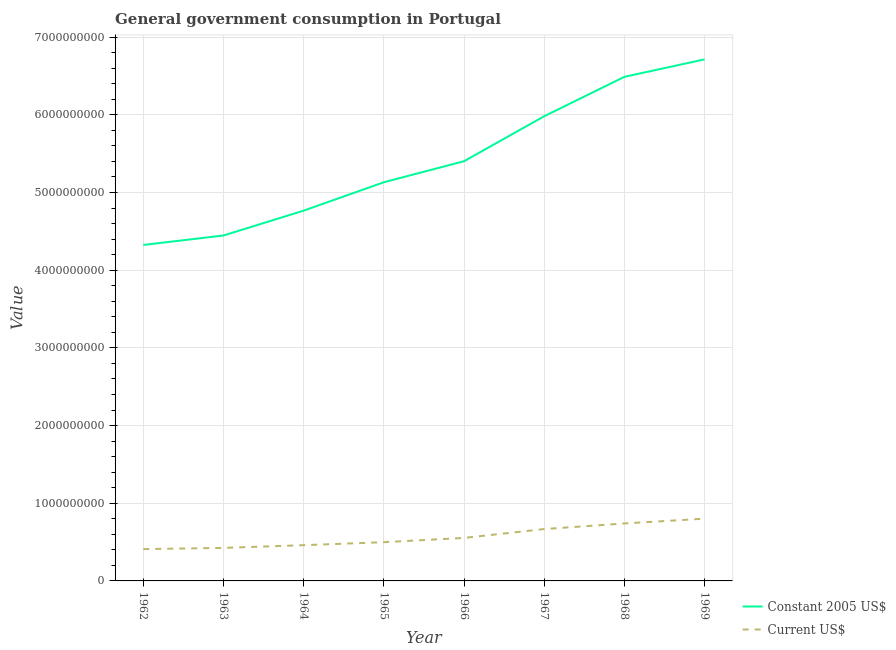How many different coloured lines are there?
Ensure brevity in your answer.  2. Does the line corresponding to value consumed in constant 2005 us$ intersect with the line corresponding to value consumed in current us$?
Your answer should be very brief. No. What is the value consumed in constant 2005 us$ in 1962?
Your answer should be compact. 4.32e+09. Across all years, what is the maximum value consumed in constant 2005 us$?
Your response must be concise. 6.71e+09. Across all years, what is the minimum value consumed in constant 2005 us$?
Keep it short and to the point. 4.32e+09. In which year was the value consumed in constant 2005 us$ maximum?
Your answer should be compact. 1969. In which year was the value consumed in constant 2005 us$ minimum?
Offer a very short reply. 1962. What is the total value consumed in constant 2005 us$ in the graph?
Your answer should be compact. 4.33e+1. What is the difference between the value consumed in constant 2005 us$ in 1963 and that in 1969?
Provide a succinct answer. -2.27e+09. What is the difference between the value consumed in current us$ in 1967 and the value consumed in constant 2005 us$ in 1963?
Offer a very short reply. -3.78e+09. What is the average value consumed in constant 2005 us$ per year?
Provide a succinct answer. 5.41e+09. In the year 1965, what is the difference between the value consumed in constant 2005 us$ and value consumed in current us$?
Offer a terse response. 4.63e+09. What is the ratio of the value consumed in current us$ in 1962 to that in 1965?
Make the answer very short. 0.82. Is the value consumed in constant 2005 us$ in 1966 less than that in 1968?
Provide a succinct answer. Yes. Is the difference between the value consumed in constant 2005 us$ in 1963 and 1965 greater than the difference between the value consumed in current us$ in 1963 and 1965?
Offer a very short reply. No. What is the difference between the highest and the second highest value consumed in constant 2005 us$?
Give a very brief answer. 2.25e+08. What is the difference between the highest and the lowest value consumed in constant 2005 us$?
Keep it short and to the point. 2.39e+09. Is the value consumed in constant 2005 us$ strictly greater than the value consumed in current us$ over the years?
Your response must be concise. Yes. Is the value consumed in constant 2005 us$ strictly less than the value consumed in current us$ over the years?
Offer a very short reply. No. How many lines are there?
Give a very brief answer. 2. How many years are there in the graph?
Make the answer very short. 8. What is the difference between two consecutive major ticks on the Y-axis?
Offer a very short reply. 1.00e+09. Are the values on the major ticks of Y-axis written in scientific E-notation?
Your answer should be compact. No. Where does the legend appear in the graph?
Your response must be concise. Bottom right. How many legend labels are there?
Offer a terse response. 2. How are the legend labels stacked?
Ensure brevity in your answer.  Vertical. What is the title of the graph?
Keep it short and to the point. General government consumption in Portugal. Does "Imports" appear as one of the legend labels in the graph?
Your answer should be compact. No. What is the label or title of the X-axis?
Your answer should be compact. Year. What is the label or title of the Y-axis?
Make the answer very short. Value. What is the Value of Constant 2005 US$ in 1962?
Ensure brevity in your answer.  4.32e+09. What is the Value of Current US$ in 1962?
Keep it short and to the point. 4.09e+08. What is the Value of Constant 2005 US$ in 1963?
Your answer should be very brief. 4.45e+09. What is the Value of Current US$ in 1963?
Your answer should be compact. 4.25e+08. What is the Value in Constant 2005 US$ in 1964?
Make the answer very short. 4.77e+09. What is the Value in Current US$ in 1964?
Offer a very short reply. 4.60e+08. What is the Value in Constant 2005 US$ in 1965?
Make the answer very short. 5.13e+09. What is the Value of Current US$ in 1965?
Offer a very short reply. 4.99e+08. What is the Value in Constant 2005 US$ in 1966?
Offer a terse response. 5.40e+09. What is the Value in Current US$ in 1966?
Ensure brevity in your answer.  5.53e+08. What is the Value of Constant 2005 US$ in 1967?
Give a very brief answer. 5.98e+09. What is the Value of Current US$ in 1967?
Make the answer very short. 6.68e+08. What is the Value of Constant 2005 US$ in 1968?
Ensure brevity in your answer.  6.49e+09. What is the Value in Current US$ in 1968?
Offer a very short reply. 7.40e+08. What is the Value in Constant 2005 US$ in 1969?
Offer a terse response. 6.71e+09. What is the Value of Current US$ in 1969?
Keep it short and to the point. 8.02e+08. Across all years, what is the maximum Value of Constant 2005 US$?
Provide a short and direct response. 6.71e+09. Across all years, what is the maximum Value of Current US$?
Your answer should be very brief. 8.02e+08. Across all years, what is the minimum Value of Constant 2005 US$?
Provide a short and direct response. 4.32e+09. Across all years, what is the minimum Value of Current US$?
Ensure brevity in your answer.  4.09e+08. What is the total Value in Constant 2005 US$ in the graph?
Your answer should be very brief. 4.33e+1. What is the total Value of Current US$ in the graph?
Your answer should be compact. 4.56e+09. What is the difference between the Value of Constant 2005 US$ in 1962 and that in 1963?
Your response must be concise. -1.22e+08. What is the difference between the Value of Current US$ in 1962 and that in 1963?
Keep it short and to the point. -1.56e+07. What is the difference between the Value in Constant 2005 US$ in 1962 and that in 1964?
Ensure brevity in your answer.  -4.42e+08. What is the difference between the Value of Current US$ in 1962 and that in 1964?
Your response must be concise. -5.07e+07. What is the difference between the Value of Constant 2005 US$ in 1962 and that in 1965?
Give a very brief answer. -8.07e+08. What is the difference between the Value in Current US$ in 1962 and that in 1965?
Your response must be concise. -8.93e+07. What is the difference between the Value of Constant 2005 US$ in 1962 and that in 1966?
Ensure brevity in your answer.  -1.08e+09. What is the difference between the Value of Current US$ in 1962 and that in 1966?
Offer a very short reply. -1.44e+08. What is the difference between the Value of Constant 2005 US$ in 1962 and that in 1967?
Offer a very short reply. -1.66e+09. What is the difference between the Value in Current US$ in 1962 and that in 1967?
Give a very brief answer. -2.58e+08. What is the difference between the Value of Constant 2005 US$ in 1962 and that in 1968?
Keep it short and to the point. -2.16e+09. What is the difference between the Value in Current US$ in 1962 and that in 1968?
Offer a very short reply. -3.30e+08. What is the difference between the Value of Constant 2005 US$ in 1962 and that in 1969?
Your answer should be compact. -2.39e+09. What is the difference between the Value of Current US$ in 1962 and that in 1969?
Give a very brief answer. -3.92e+08. What is the difference between the Value of Constant 2005 US$ in 1963 and that in 1964?
Provide a short and direct response. -3.20e+08. What is the difference between the Value in Current US$ in 1963 and that in 1964?
Provide a short and direct response. -3.51e+07. What is the difference between the Value of Constant 2005 US$ in 1963 and that in 1965?
Your answer should be very brief. -6.85e+08. What is the difference between the Value of Current US$ in 1963 and that in 1965?
Offer a terse response. -7.37e+07. What is the difference between the Value in Constant 2005 US$ in 1963 and that in 1966?
Make the answer very short. -9.56e+08. What is the difference between the Value of Current US$ in 1963 and that in 1966?
Your response must be concise. -1.28e+08. What is the difference between the Value of Constant 2005 US$ in 1963 and that in 1967?
Offer a terse response. -1.54e+09. What is the difference between the Value in Current US$ in 1963 and that in 1967?
Keep it short and to the point. -2.43e+08. What is the difference between the Value in Constant 2005 US$ in 1963 and that in 1968?
Provide a short and direct response. -2.04e+09. What is the difference between the Value of Current US$ in 1963 and that in 1968?
Offer a very short reply. -3.15e+08. What is the difference between the Value in Constant 2005 US$ in 1963 and that in 1969?
Your answer should be compact. -2.27e+09. What is the difference between the Value of Current US$ in 1963 and that in 1969?
Your answer should be very brief. -3.77e+08. What is the difference between the Value in Constant 2005 US$ in 1964 and that in 1965?
Ensure brevity in your answer.  -3.65e+08. What is the difference between the Value of Current US$ in 1964 and that in 1965?
Offer a very short reply. -3.86e+07. What is the difference between the Value in Constant 2005 US$ in 1964 and that in 1966?
Ensure brevity in your answer.  -6.36e+08. What is the difference between the Value of Current US$ in 1964 and that in 1966?
Give a very brief answer. -9.33e+07. What is the difference between the Value in Constant 2005 US$ in 1964 and that in 1967?
Make the answer very short. -1.22e+09. What is the difference between the Value of Current US$ in 1964 and that in 1967?
Offer a terse response. -2.08e+08. What is the difference between the Value of Constant 2005 US$ in 1964 and that in 1968?
Ensure brevity in your answer.  -1.72e+09. What is the difference between the Value of Current US$ in 1964 and that in 1968?
Provide a succinct answer. -2.80e+08. What is the difference between the Value of Constant 2005 US$ in 1964 and that in 1969?
Give a very brief answer. -1.95e+09. What is the difference between the Value of Current US$ in 1964 and that in 1969?
Offer a very short reply. -3.41e+08. What is the difference between the Value of Constant 2005 US$ in 1965 and that in 1966?
Provide a succinct answer. -2.71e+08. What is the difference between the Value of Current US$ in 1965 and that in 1966?
Make the answer very short. -5.48e+07. What is the difference between the Value of Constant 2005 US$ in 1965 and that in 1967?
Your response must be concise. -8.50e+08. What is the difference between the Value in Current US$ in 1965 and that in 1967?
Your answer should be very brief. -1.69e+08. What is the difference between the Value in Constant 2005 US$ in 1965 and that in 1968?
Provide a short and direct response. -1.36e+09. What is the difference between the Value of Current US$ in 1965 and that in 1968?
Provide a succinct answer. -2.41e+08. What is the difference between the Value in Constant 2005 US$ in 1965 and that in 1969?
Keep it short and to the point. -1.58e+09. What is the difference between the Value in Current US$ in 1965 and that in 1969?
Provide a short and direct response. -3.03e+08. What is the difference between the Value in Constant 2005 US$ in 1966 and that in 1967?
Offer a terse response. -5.79e+08. What is the difference between the Value of Current US$ in 1966 and that in 1967?
Make the answer very short. -1.14e+08. What is the difference between the Value of Constant 2005 US$ in 1966 and that in 1968?
Offer a very short reply. -1.09e+09. What is the difference between the Value in Current US$ in 1966 and that in 1968?
Keep it short and to the point. -1.86e+08. What is the difference between the Value in Constant 2005 US$ in 1966 and that in 1969?
Keep it short and to the point. -1.31e+09. What is the difference between the Value of Current US$ in 1966 and that in 1969?
Provide a succinct answer. -2.48e+08. What is the difference between the Value of Constant 2005 US$ in 1967 and that in 1968?
Offer a very short reply. -5.08e+08. What is the difference between the Value of Current US$ in 1967 and that in 1968?
Your answer should be very brief. -7.22e+07. What is the difference between the Value of Constant 2005 US$ in 1967 and that in 1969?
Your answer should be compact. -7.32e+08. What is the difference between the Value in Current US$ in 1967 and that in 1969?
Your response must be concise. -1.34e+08. What is the difference between the Value of Constant 2005 US$ in 1968 and that in 1969?
Provide a short and direct response. -2.25e+08. What is the difference between the Value of Current US$ in 1968 and that in 1969?
Your response must be concise. -6.18e+07. What is the difference between the Value in Constant 2005 US$ in 1962 and the Value in Current US$ in 1963?
Your response must be concise. 3.90e+09. What is the difference between the Value of Constant 2005 US$ in 1962 and the Value of Current US$ in 1964?
Give a very brief answer. 3.86e+09. What is the difference between the Value in Constant 2005 US$ in 1962 and the Value in Current US$ in 1965?
Your answer should be compact. 3.83e+09. What is the difference between the Value of Constant 2005 US$ in 1962 and the Value of Current US$ in 1966?
Your response must be concise. 3.77e+09. What is the difference between the Value of Constant 2005 US$ in 1962 and the Value of Current US$ in 1967?
Your response must be concise. 3.66e+09. What is the difference between the Value of Constant 2005 US$ in 1962 and the Value of Current US$ in 1968?
Provide a succinct answer. 3.59e+09. What is the difference between the Value of Constant 2005 US$ in 1962 and the Value of Current US$ in 1969?
Give a very brief answer. 3.52e+09. What is the difference between the Value in Constant 2005 US$ in 1963 and the Value in Current US$ in 1964?
Make the answer very short. 3.99e+09. What is the difference between the Value of Constant 2005 US$ in 1963 and the Value of Current US$ in 1965?
Ensure brevity in your answer.  3.95e+09. What is the difference between the Value in Constant 2005 US$ in 1963 and the Value in Current US$ in 1966?
Your answer should be very brief. 3.89e+09. What is the difference between the Value of Constant 2005 US$ in 1963 and the Value of Current US$ in 1967?
Offer a terse response. 3.78e+09. What is the difference between the Value of Constant 2005 US$ in 1963 and the Value of Current US$ in 1968?
Make the answer very short. 3.71e+09. What is the difference between the Value of Constant 2005 US$ in 1963 and the Value of Current US$ in 1969?
Your answer should be compact. 3.65e+09. What is the difference between the Value in Constant 2005 US$ in 1964 and the Value in Current US$ in 1965?
Provide a short and direct response. 4.27e+09. What is the difference between the Value of Constant 2005 US$ in 1964 and the Value of Current US$ in 1966?
Keep it short and to the point. 4.21e+09. What is the difference between the Value of Constant 2005 US$ in 1964 and the Value of Current US$ in 1967?
Keep it short and to the point. 4.10e+09. What is the difference between the Value of Constant 2005 US$ in 1964 and the Value of Current US$ in 1968?
Your response must be concise. 4.03e+09. What is the difference between the Value in Constant 2005 US$ in 1964 and the Value in Current US$ in 1969?
Provide a succinct answer. 3.96e+09. What is the difference between the Value of Constant 2005 US$ in 1965 and the Value of Current US$ in 1966?
Provide a succinct answer. 4.58e+09. What is the difference between the Value of Constant 2005 US$ in 1965 and the Value of Current US$ in 1967?
Offer a very short reply. 4.46e+09. What is the difference between the Value in Constant 2005 US$ in 1965 and the Value in Current US$ in 1968?
Provide a succinct answer. 4.39e+09. What is the difference between the Value of Constant 2005 US$ in 1965 and the Value of Current US$ in 1969?
Give a very brief answer. 4.33e+09. What is the difference between the Value in Constant 2005 US$ in 1966 and the Value in Current US$ in 1967?
Ensure brevity in your answer.  4.74e+09. What is the difference between the Value in Constant 2005 US$ in 1966 and the Value in Current US$ in 1968?
Keep it short and to the point. 4.66e+09. What is the difference between the Value in Constant 2005 US$ in 1966 and the Value in Current US$ in 1969?
Your response must be concise. 4.60e+09. What is the difference between the Value in Constant 2005 US$ in 1967 and the Value in Current US$ in 1968?
Provide a short and direct response. 5.24e+09. What is the difference between the Value of Constant 2005 US$ in 1967 and the Value of Current US$ in 1969?
Offer a terse response. 5.18e+09. What is the difference between the Value in Constant 2005 US$ in 1968 and the Value in Current US$ in 1969?
Your answer should be very brief. 5.69e+09. What is the average Value of Constant 2005 US$ per year?
Ensure brevity in your answer.  5.41e+09. What is the average Value of Current US$ per year?
Offer a very short reply. 5.70e+08. In the year 1962, what is the difference between the Value in Constant 2005 US$ and Value in Current US$?
Give a very brief answer. 3.92e+09. In the year 1963, what is the difference between the Value of Constant 2005 US$ and Value of Current US$?
Your response must be concise. 4.02e+09. In the year 1964, what is the difference between the Value in Constant 2005 US$ and Value in Current US$?
Give a very brief answer. 4.31e+09. In the year 1965, what is the difference between the Value of Constant 2005 US$ and Value of Current US$?
Your response must be concise. 4.63e+09. In the year 1966, what is the difference between the Value of Constant 2005 US$ and Value of Current US$?
Your answer should be compact. 4.85e+09. In the year 1967, what is the difference between the Value in Constant 2005 US$ and Value in Current US$?
Your response must be concise. 5.31e+09. In the year 1968, what is the difference between the Value in Constant 2005 US$ and Value in Current US$?
Give a very brief answer. 5.75e+09. In the year 1969, what is the difference between the Value in Constant 2005 US$ and Value in Current US$?
Offer a terse response. 5.91e+09. What is the ratio of the Value in Constant 2005 US$ in 1962 to that in 1963?
Offer a terse response. 0.97. What is the ratio of the Value in Current US$ in 1962 to that in 1963?
Keep it short and to the point. 0.96. What is the ratio of the Value of Constant 2005 US$ in 1962 to that in 1964?
Offer a very short reply. 0.91. What is the ratio of the Value in Current US$ in 1962 to that in 1964?
Your response must be concise. 0.89. What is the ratio of the Value of Constant 2005 US$ in 1962 to that in 1965?
Give a very brief answer. 0.84. What is the ratio of the Value in Current US$ in 1962 to that in 1965?
Offer a very short reply. 0.82. What is the ratio of the Value in Constant 2005 US$ in 1962 to that in 1966?
Your answer should be compact. 0.8. What is the ratio of the Value in Current US$ in 1962 to that in 1966?
Your answer should be very brief. 0.74. What is the ratio of the Value of Constant 2005 US$ in 1962 to that in 1967?
Provide a short and direct response. 0.72. What is the ratio of the Value of Current US$ in 1962 to that in 1967?
Offer a very short reply. 0.61. What is the ratio of the Value of Constant 2005 US$ in 1962 to that in 1968?
Your response must be concise. 0.67. What is the ratio of the Value in Current US$ in 1962 to that in 1968?
Your answer should be very brief. 0.55. What is the ratio of the Value in Constant 2005 US$ in 1962 to that in 1969?
Make the answer very short. 0.64. What is the ratio of the Value of Current US$ in 1962 to that in 1969?
Your answer should be very brief. 0.51. What is the ratio of the Value of Constant 2005 US$ in 1963 to that in 1964?
Provide a short and direct response. 0.93. What is the ratio of the Value of Current US$ in 1963 to that in 1964?
Your answer should be compact. 0.92. What is the ratio of the Value in Constant 2005 US$ in 1963 to that in 1965?
Keep it short and to the point. 0.87. What is the ratio of the Value of Current US$ in 1963 to that in 1965?
Your answer should be very brief. 0.85. What is the ratio of the Value of Constant 2005 US$ in 1963 to that in 1966?
Offer a terse response. 0.82. What is the ratio of the Value in Current US$ in 1963 to that in 1966?
Provide a succinct answer. 0.77. What is the ratio of the Value in Constant 2005 US$ in 1963 to that in 1967?
Provide a succinct answer. 0.74. What is the ratio of the Value in Current US$ in 1963 to that in 1967?
Your answer should be compact. 0.64. What is the ratio of the Value of Constant 2005 US$ in 1963 to that in 1968?
Your response must be concise. 0.69. What is the ratio of the Value in Current US$ in 1963 to that in 1968?
Provide a short and direct response. 0.57. What is the ratio of the Value in Constant 2005 US$ in 1963 to that in 1969?
Keep it short and to the point. 0.66. What is the ratio of the Value in Current US$ in 1963 to that in 1969?
Ensure brevity in your answer.  0.53. What is the ratio of the Value of Constant 2005 US$ in 1964 to that in 1965?
Provide a succinct answer. 0.93. What is the ratio of the Value in Current US$ in 1964 to that in 1965?
Keep it short and to the point. 0.92. What is the ratio of the Value of Constant 2005 US$ in 1964 to that in 1966?
Provide a succinct answer. 0.88. What is the ratio of the Value of Current US$ in 1964 to that in 1966?
Your response must be concise. 0.83. What is the ratio of the Value of Constant 2005 US$ in 1964 to that in 1967?
Your answer should be compact. 0.8. What is the ratio of the Value in Current US$ in 1964 to that in 1967?
Your answer should be compact. 0.69. What is the ratio of the Value in Constant 2005 US$ in 1964 to that in 1968?
Keep it short and to the point. 0.73. What is the ratio of the Value of Current US$ in 1964 to that in 1968?
Offer a very short reply. 0.62. What is the ratio of the Value of Constant 2005 US$ in 1964 to that in 1969?
Your answer should be very brief. 0.71. What is the ratio of the Value of Current US$ in 1964 to that in 1969?
Your answer should be very brief. 0.57. What is the ratio of the Value of Constant 2005 US$ in 1965 to that in 1966?
Give a very brief answer. 0.95. What is the ratio of the Value in Current US$ in 1965 to that in 1966?
Make the answer very short. 0.9. What is the ratio of the Value of Constant 2005 US$ in 1965 to that in 1967?
Offer a terse response. 0.86. What is the ratio of the Value in Current US$ in 1965 to that in 1967?
Offer a very short reply. 0.75. What is the ratio of the Value of Constant 2005 US$ in 1965 to that in 1968?
Provide a short and direct response. 0.79. What is the ratio of the Value in Current US$ in 1965 to that in 1968?
Your response must be concise. 0.67. What is the ratio of the Value of Constant 2005 US$ in 1965 to that in 1969?
Your answer should be compact. 0.76. What is the ratio of the Value in Current US$ in 1965 to that in 1969?
Give a very brief answer. 0.62. What is the ratio of the Value in Constant 2005 US$ in 1966 to that in 1967?
Your response must be concise. 0.9. What is the ratio of the Value of Current US$ in 1966 to that in 1967?
Your answer should be very brief. 0.83. What is the ratio of the Value in Constant 2005 US$ in 1966 to that in 1968?
Provide a succinct answer. 0.83. What is the ratio of the Value of Current US$ in 1966 to that in 1968?
Provide a succinct answer. 0.75. What is the ratio of the Value of Constant 2005 US$ in 1966 to that in 1969?
Offer a very short reply. 0.8. What is the ratio of the Value of Current US$ in 1966 to that in 1969?
Keep it short and to the point. 0.69. What is the ratio of the Value in Constant 2005 US$ in 1967 to that in 1968?
Offer a terse response. 0.92. What is the ratio of the Value in Current US$ in 1967 to that in 1968?
Your response must be concise. 0.9. What is the ratio of the Value of Constant 2005 US$ in 1967 to that in 1969?
Ensure brevity in your answer.  0.89. What is the ratio of the Value of Current US$ in 1967 to that in 1969?
Ensure brevity in your answer.  0.83. What is the ratio of the Value of Constant 2005 US$ in 1968 to that in 1969?
Keep it short and to the point. 0.97. What is the ratio of the Value in Current US$ in 1968 to that in 1969?
Provide a succinct answer. 0.92. What is the difference between the highest and the second highest Value in Constant 2005 US$?
Your answer should be compact. 2.25e+08. What is the difference between the highest and the second highest Value in Current US$?
Offer a very short reply. 6.18e+07. What is the difference between the highest and the lowest Value in Constant 2005 US$?
Your response must be concise. 2.39e+09. What is the difference between the highest and the lowest Value of Current US$?
Your answer should be compact. 3.92e+08. 